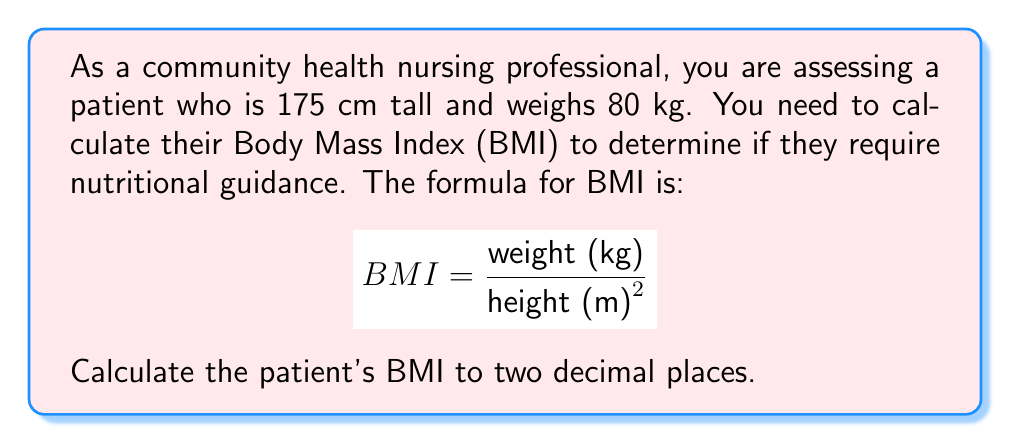Help me with this question. To calculate the BMI, we need to follow these steps:

1. Convert the height from centimeters to meters:
   $175 \text{ cm} = 1.75 \text{ m}$

2. Square the height in meters:
   $1.75^2 = 3.0625 \text{ m}^2$

3. Divide the weight in kilograms by the squared height:
   $$ BMI = \frac{80 \text{ kg}}{3.0625 \text{ m}^2} $$

4. Perform the division:
   $$ BMI = 26.1224489795918 $$

5. Round to two decimal places:
   $$ BMI \approx 26.12 $$
Answer: $26.12$ 